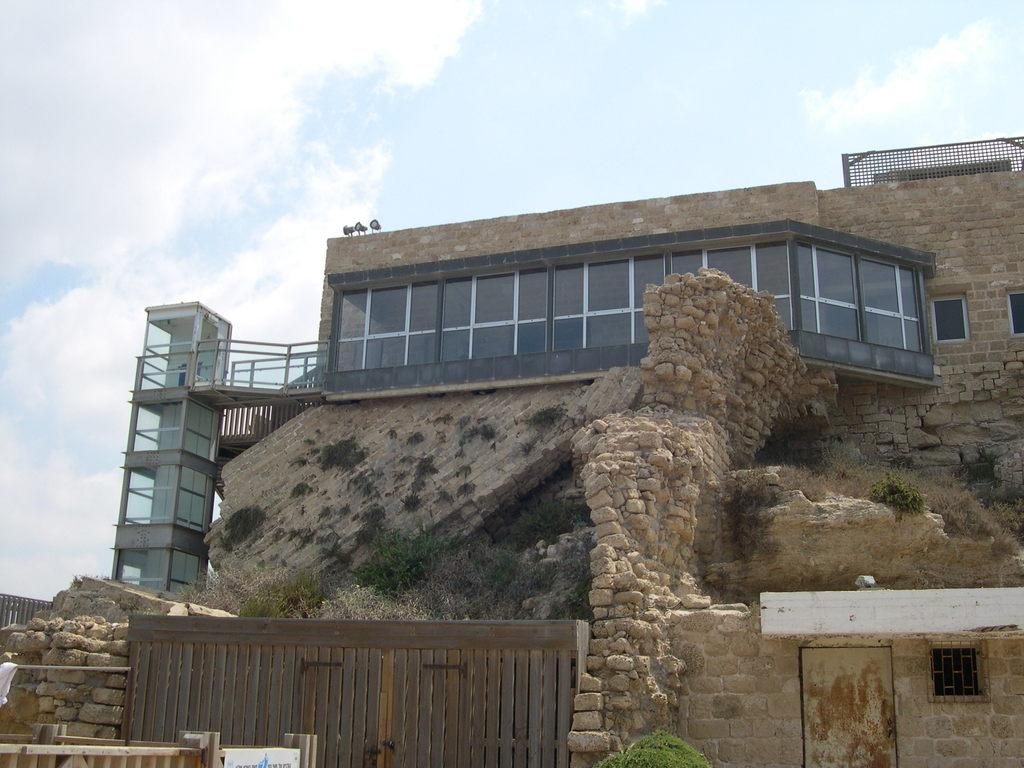What is the main structure in the center of the image? There is a building in the center of the image. What is located at the bottom of the image? There is a wooden gate at the bottom of the image. Can you identify any vegetation in the image? Yes, there is a plant in the image. What is visible at the top of the image? The sky is visible at the top of the image. What can be observed in the sky? Clouds are present in the sky. Where is the laborer working in the image? There is no laborer present in the image. What type of bird can be seen perched on the plant in the image? There is no bird, specifically a wren, present in the image. 